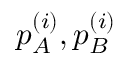<formula> <loc_0><loc_0><loc_500><loc_500>p _ { A } ^ { ( i ) } , p _ { B } ^ { ( i ) }</formula> 